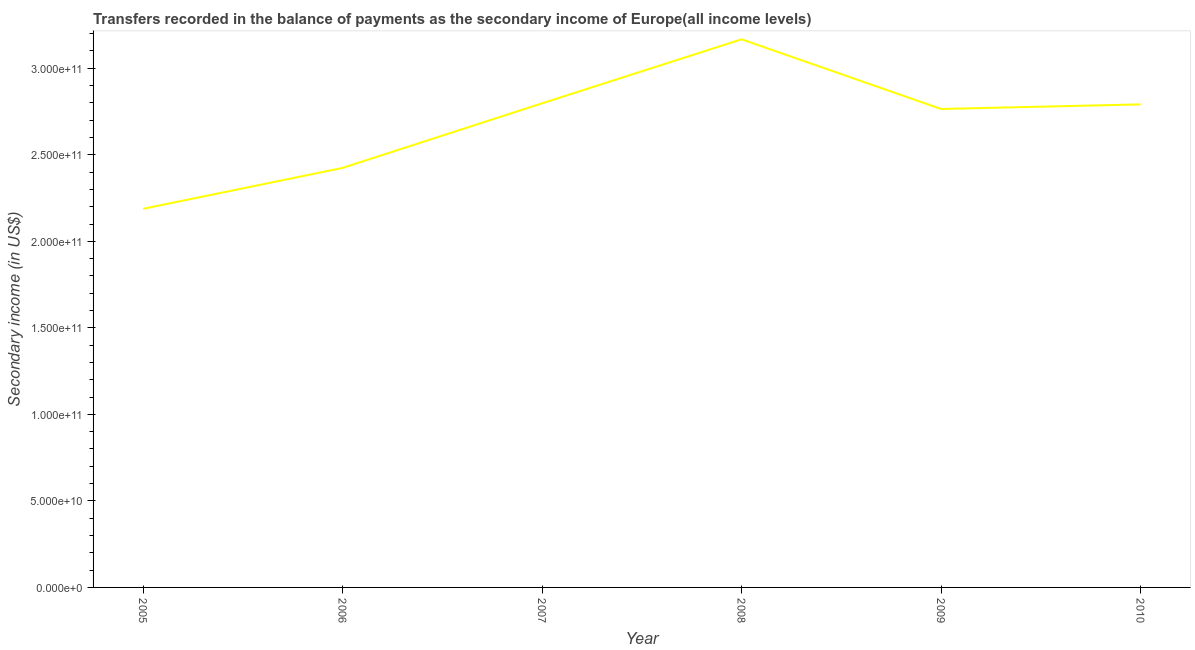What is the amount of secondary income in 2006?
Keep it short and to the point. 2.42e+11. Across all years, what is the maximum amount of secondary income?
Offer a very short reply. 3.17e+11. Across all years, what is the minimum amount of secondary income?
Make the answer very short. 2.19e+11. In which year was the amount of secondary income maximum?
Make the answer very short. 2008. What is the sum of the amount of secondary income?
Offer a very short reply. 1.61e+12. What is the difference between the amount of secondary income in 2007 and 2008?
Your response must be concise. -3.70e+1. What is the average amount of secondary income per year?
Give a very brief answer. 2.69e+11. What is the median amount of secondary income?
Ensure brevity in your answer.  2.78e+11. Do a majority of the years between 2006 and 2005 (inclusive) have amount of secondary income greater than 60000000000 US$?
Provide a succinct answer. No. What is the ratio of the amount of secondary income in 2006 to that in 2008?
Ensure brevity in your answer.  0.77. Is the amount of secondary income in 2006 less than that in 2010?
Your response must be concise. Yes. Is the difference between the amount of secondary income in 2005 and 2009 greater than the difference between any two years?
Your response must be concise. No. What is the difference between the highest and the second highest amount of secondary income?
Make the answer very short. 3.70e+1. Is the sum of the amount of secondary income in 2007 and 2009 greater than the maximum amount of secondary income across all years?
Your answer should be very brief. Yes. What is the difference between the highest and the lowest amount of secondary income?
Give a very brief answer. 9.80e+1. Does the graph contain grids?
Your response must be concise. No. What is the title of the graph?
Your answer should be very brief. Transfers recorded in the balance of payments as the secondary income of Europe(all income levels). What is the label or title of the X-axis?
Give a very brief answer. Year. What is the label or title of the Y-axis?
Keep it short and to the point. Secondary income (in US$). What is the Secondary income (in US$) of 2005?
Your response must be concise. 2.19e+11. What is the Secondary income (in US$) in 2006?
Your response must be concise. 2.42e+11. What is the Secondary income (in US$) in 2007?
Provide a short and direct response. 2.80e+11. What is the Secondary income (in US$) of 2008?
Offer a very short reply. 3.17e+11. What is the Secondary income (in US$) of 2009?
Offer a very short reply. 2.76e+11. What is the Secondary income (in US$) of 2010?
Keep it short and to the point. 2.79e+11. What is the difference between the Secondary income (in US$) in 2005 and 2006?
Your answer should be very brief. -2.36e+1. What is the difference between the Secondary income (in US$) in 2005 and 2007?
Your answer should be compact. -6.10e+1. What is the difference between the Secondary income (in US$) in 2005 and 2008?
Your response must be concise. -9.80e+1. What is the difference between the Secondary income (in US$) in 2005 and 2009?
Your response must be concise. -5.77e+1. What is the difference between the Secondary income (in US$) in 2005 and 2010?
Keep it short and to the point. -6.03e+1. What is the difference between the Secondary income (in US$) in 2006 and 2007?
Offer a very short reply. -3.73e+1. What is the difference between the Secondary income (in US$) in 2006 and 2008?
Offer a terse response. -7.43e+1. What is the difference between the Secondary income (in US$) in 2006 and 2009?
Give a very brief answer. -3.41e+1. What is the difference between the Secondary income (in US$) in 2006 and 2010?
Offer a terse response. -3.67e+1. What is the difference between the Secondary income (in US$) in 2007 and 2008?
Offer a very short reply. -3.70e+1. What is the difference between the Secondary income (in US$) in 2007 and 2009?
Your answer should be very brief. 3.27e+09. What is the difference between the Secondary income (in US$) in 2007 and 2010?
Provide a short and direct response. 6.19e+08. What is the difference between the Secondary income (in US$) in 2008 and 2009?
Keep it short and to the point. 4.03e+1. What is the difference between the Secondary income (in US$) in 2008 and 2010?
Provide a short and direct response. 3.76e+1. What is the difference between the Secondary income (in US$) in 2009 and 2010?
Provide a succinct answer. -2.65e+09. What is the ratio of the Secondary income (in US$) in 2005 to that in 2006?
Your response must be concise. 0.9. What is the ratio of the Secondary income (in US$) in 2005 to that in 2007?
Keep it short and to the point. 0.78. What is the ratio of the Secondary income (in US$) in 2005 to that in 2008?
Your response must be concise. 0.69. What is the ratio of the Secondary income (in US$) in 2005 to that in 2009?
Keep it short and to the point. 0.79. What is the ratio of the Secondary income (in US$) in 2005 to that in 2010?
Your response must be concise. 0.78. What is the ratio of the Secondary income (in US$) in 2006 to that in 2007?
Ensure brevity in your answer.  0.87. What is the ratio of the Secondary income (in US$) in 2006 to that in 2008?
Ensure brevity in your answer.  0.77. What is the ratio of the Secondary income (in US$) in 2006 to that in 2009?
Keep it short and to the point. 0.88. What is the ratio of the Secondary income (in US$) in 2006 to that in 2010?
Offer a very short reply. 0.87. What is the ratio of the Secondary income (in US$) in 2007 to that in 2008?
Keep it short and to the point. 0.88. What is the ratio of the Secondary income (in US$) in 2007 to that in 2009?
Your response must be concise. 1.01. What is the ratio of the Secondary income (in US$) in 2008 to that in 2009?
Make the answer very short. 1.15. What is the ratio of the Secondary income (in US$) in 2008 to that in 2010?
Offer a very short reply. 1.14. What is the ratio of the Secondary income (in US$) in 2009 to that in 2010?
Give a very brief answer. 0.99. 